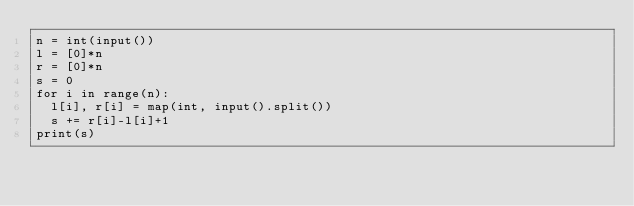Convert code to text. <code><loc_0><loc_0><loc_500><loc_500><_Python_>n = int(input())
l = [0]*n
r = [0]*n
s = 0
for i in range(n):
  l[i], r[i] = map(int, input().split())
  s += r[i]-l[i]+1
print(s)</code> 